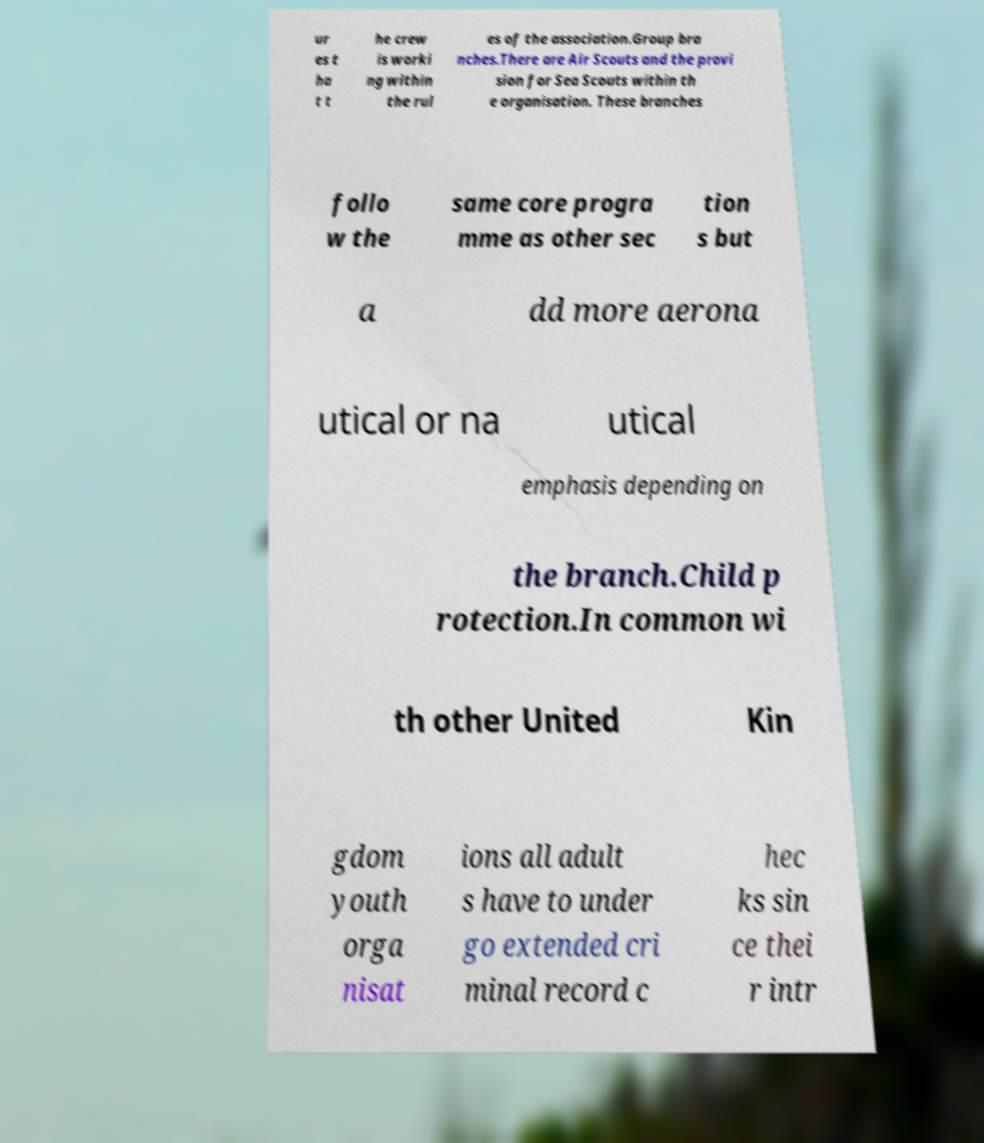Can you read and provide the text displayed in the image?This photo seems to have some interesting text. Can you extract and type it out for me? ur es t ha t t he crew is worki ng within the rul es of the association.Group bra nches.There are Air Scouts and the provi sion for Sea Scouts within th e organisation. These branches follo w the same core progra mme as other sec tion s but a dd more aerona utical or na utical emphasis depending on the branch.Child p rotection.In common wi th other United Kin gdom youth orga nisat ions all adult s have to under go extended cri minal record c hec ks sin ce thei r intr 